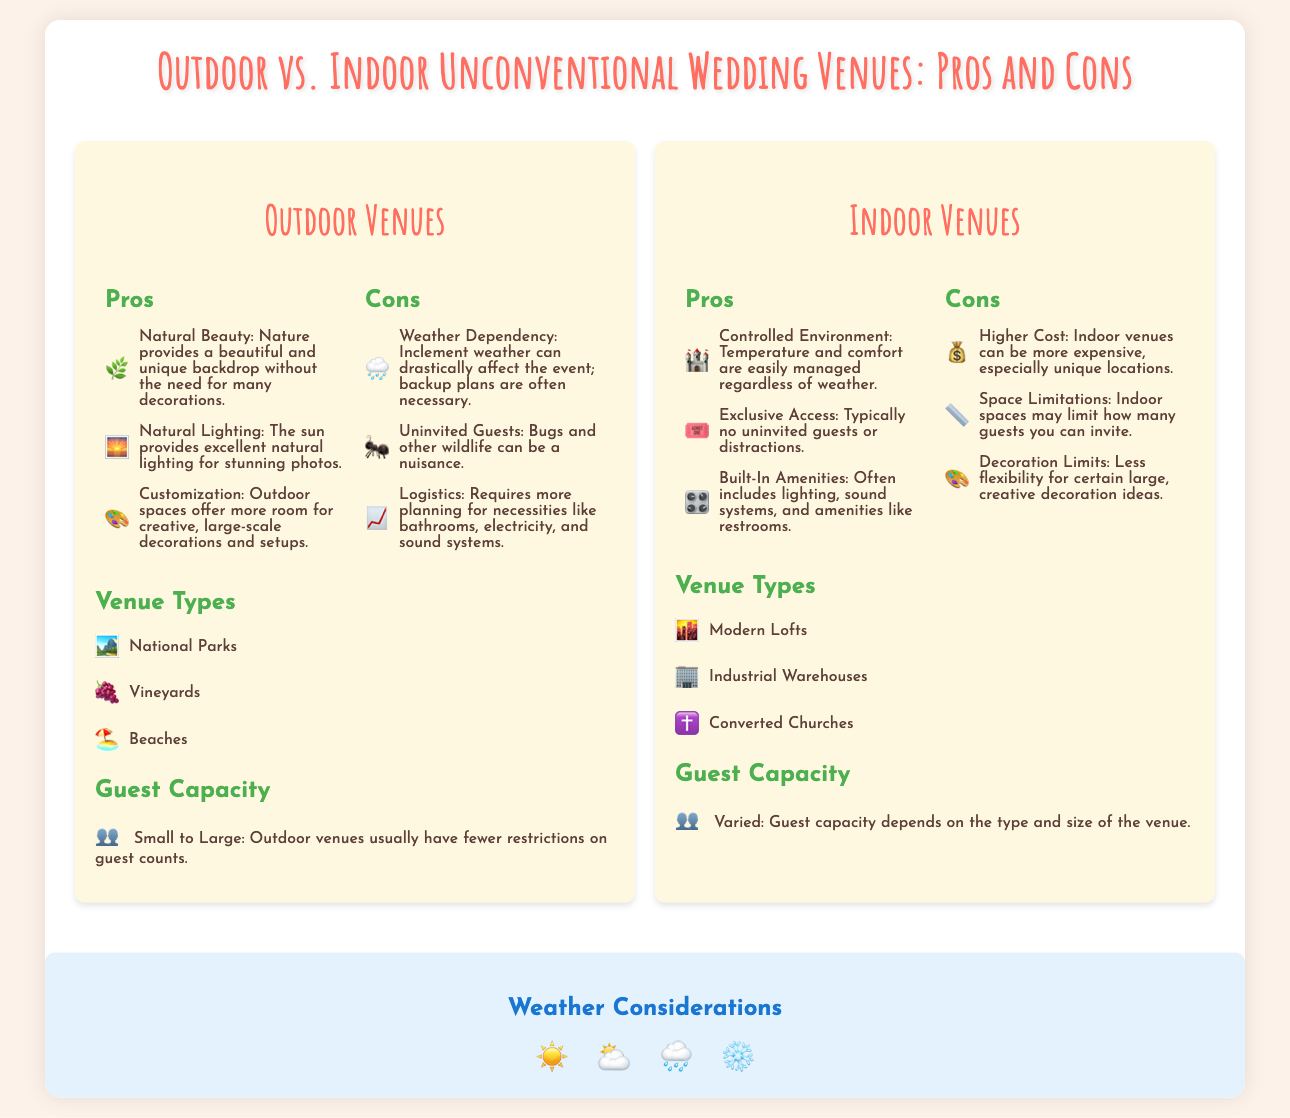What are the pros of outdoor venues? The document lists three pros for outdoor venues: Natural Beauty, Natural Lighting, and Customization.
Answer: Natural Beauty, Natural Lighting, Customization What is a con of indoor venues? The document lists three cons for indoor venues, and one of them is Higher Cost.
Answer: Higher Cost What types of venues are listed for outdoor weddings? The document mentions three types of outdoor venues: National Parks, Vineyards, and Beaches.
Answer: National Parks, Vineyards, Beaches What icons represent weather considerations? The weather icons include Sunny, Cloudy, Rainy, and Snowy.
Answer: Sunny, Cloudy, Rainy, Snowy Which venue type has a controlled environment? The document states that Indoor Venues have a controlled environment.
Answer: Indoor Venues What is a shared pro between both outdoor and indoor venues? Both venue types share the opportunity for unique experiences, highlighting different pros. Natural Beauty is a pro for outdoor, while Controlled Environment is a pro for indoor, but both offer creativity.
Answer: Unique experiences What is the guest capacity for outdoor venues? The document indicates that outdoor venues usually have fewer restrictions on guest counts.
Answer: Small to Large How many cons are listed for outdoor venues? The document lists three cons for outdoor venues, highlighting Weather Dependency, Uninvited Guests, and Logistics.
Answer: Three What is the guest capacity for indoor venues? The guest capacity for indoor venues varies depending on the type and size of the venue.
Answer: Varied 